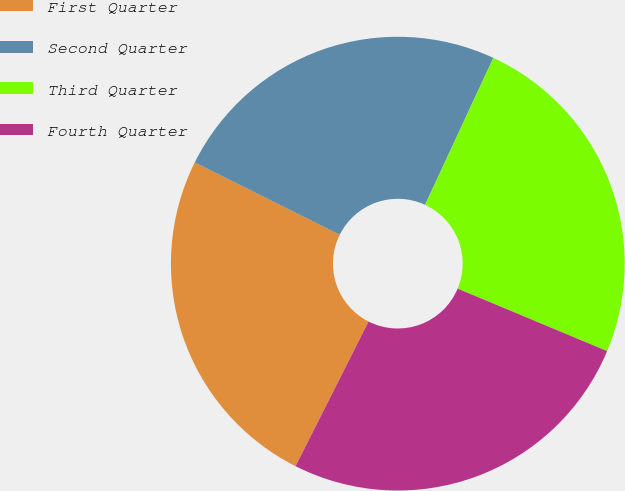Convert chart to OTSL. <chart><loc_0><loc_0><loc_500><loc_500><pie_chart><fcel>First Quarter<fcel>Second Quarter<fcel>Third Quarter<fcel>Fourth Quarter<nl><fcel>24.92%<fcel>24.56%<fcel>24.38%<fcel>26.14%<nl></chart> 